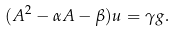<formula> <loc_0><loc_0><loc_500><loc_500>( A ^ { 2 } - \alpha A - \beta ) u = \gamma g .</formula> 